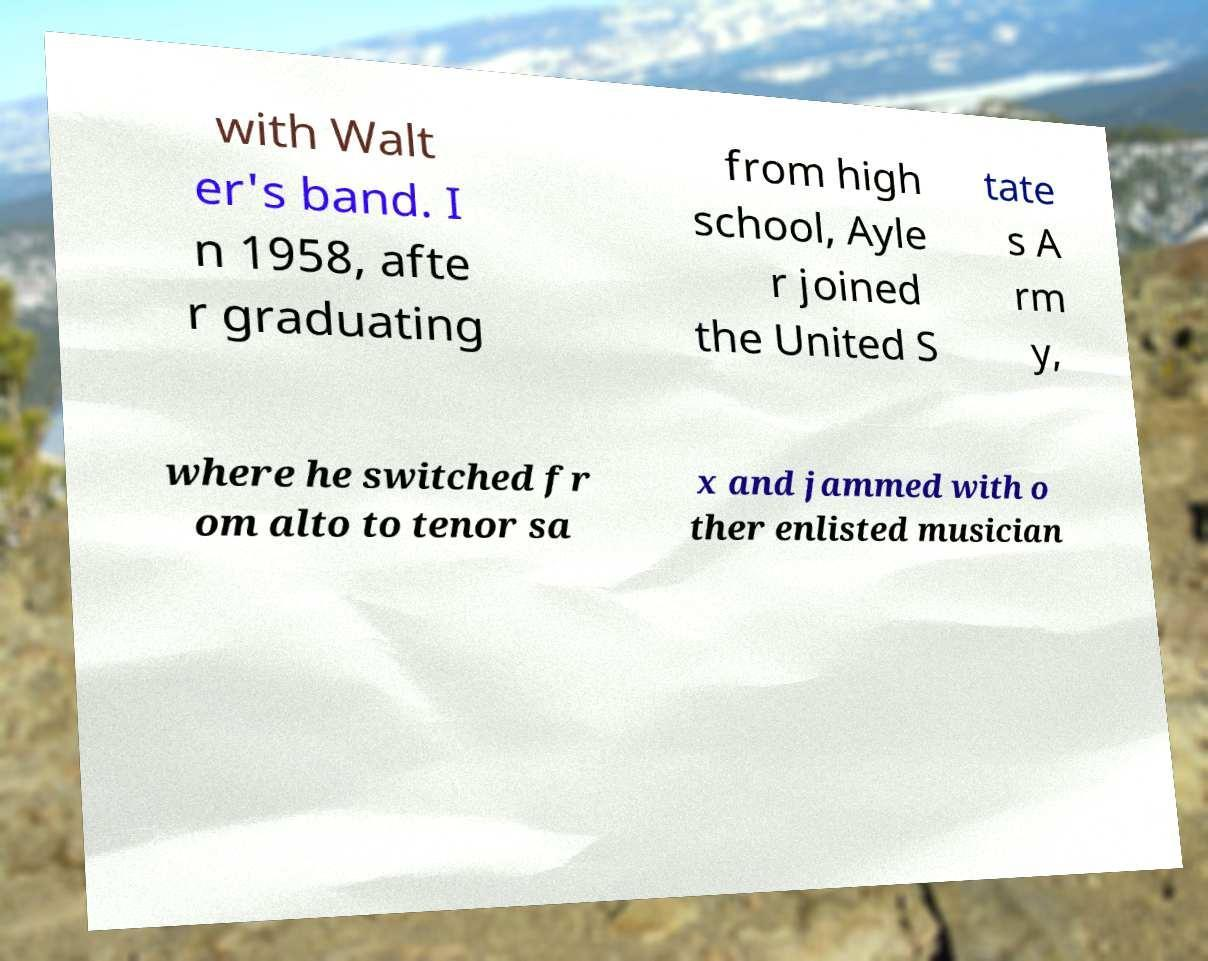I need the written content from this picture converted into text. Can you do that? with Walt er's band. I n 1958, afte r graduating from high school, Ayle r joined the United S tate s A rm y, where he switched fr om alto to tenor sa x and jammed with o ther enlisted musician 